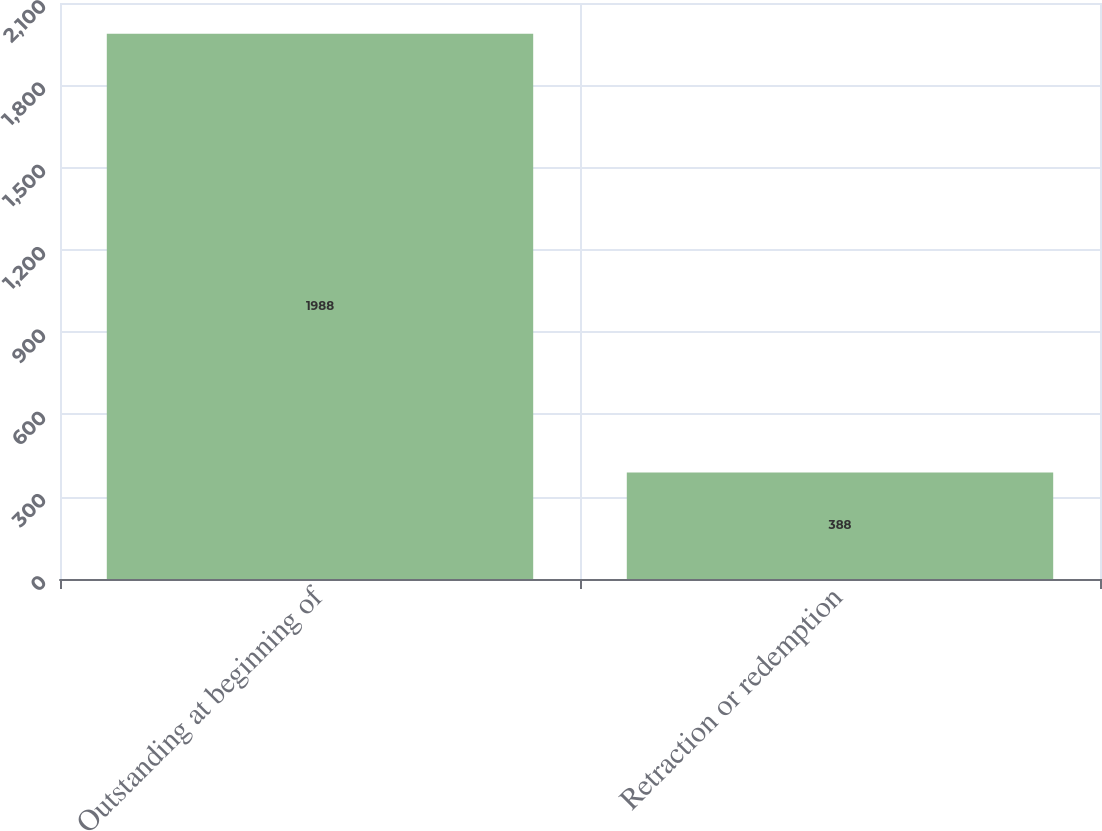<chart> <loc_0><loc_0><loc_500><loc_500><bar_chart><fcel>Outstanding at beginning of<fcel>Retraction or redemption<nl><fcel>1988<fcel>388<nl></chart> 